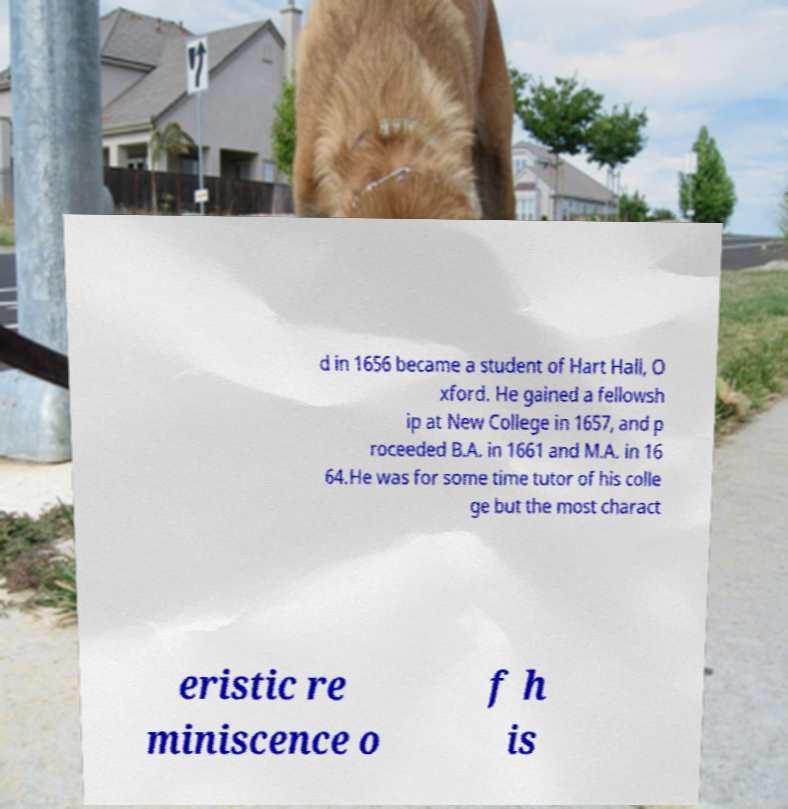There's text embedded in this image that I need extracted. Can you transcribe it verbatim? d in 1656 became a student of Hart Hall, O xford. He gained a fellowsh ip at New College in 1657, and p roceeded B.A. in 1661 and M.A. in 16 64.He was for some time tutor of his colle ge but the most charact eristic re miniscence o f h is 